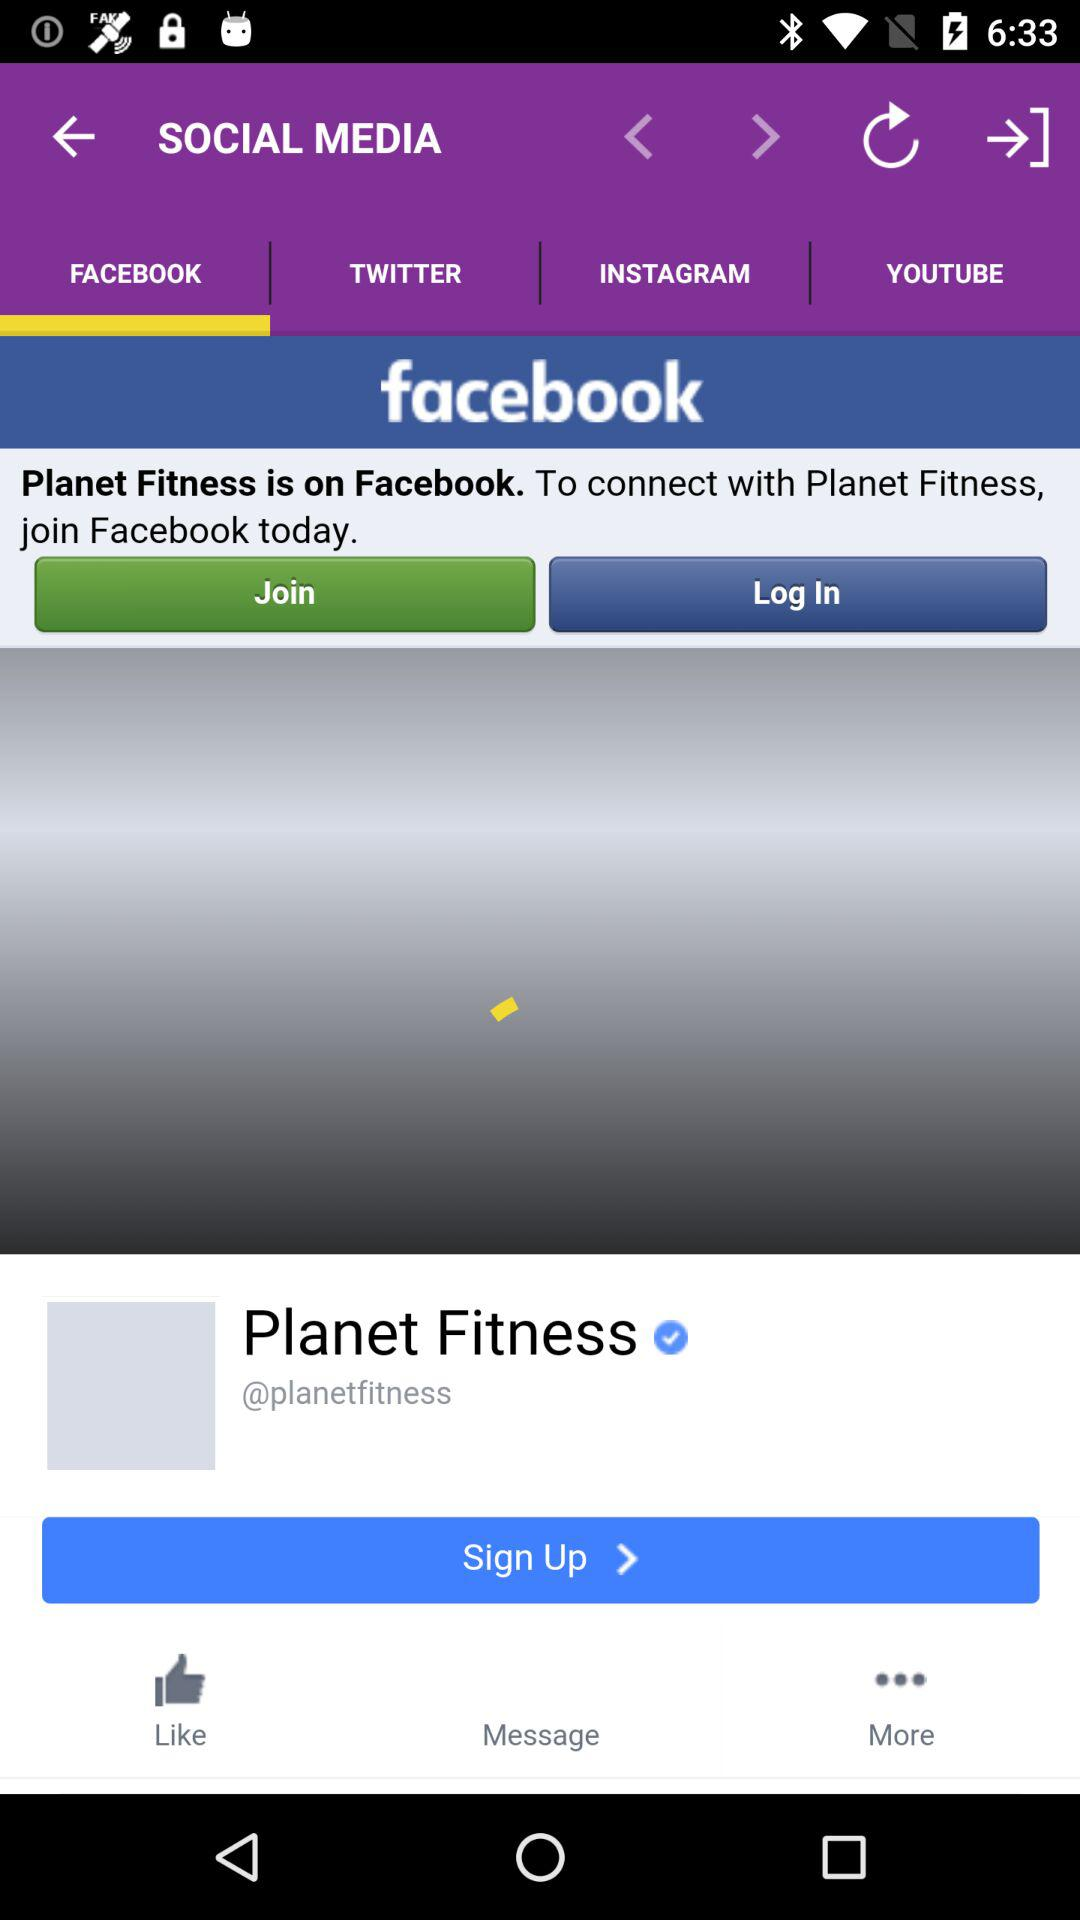Which tab is currently selected? The currently selected tab is "FACEBOOK". 